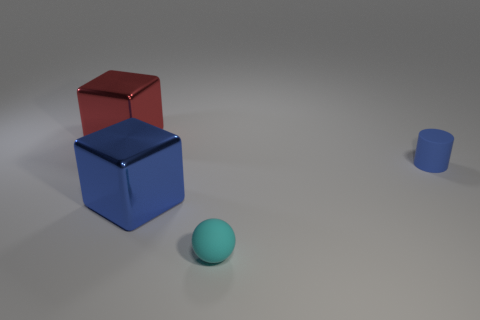Add 2 rubber balls. How many objects exist? 6 Subtract all cylinders. How many objects are left? 3 Add 1 tiny cyan matte balls. How many tiny cyan matte balls are left? 2 Add 3 blue shiny blocks. How many blue shiny blocks exist? 4 Subtract 0 purple balls. How many objects are left? 4 Subtract all red metallic objects. Subtract all tiny cyan balls. How many objects are left? 2 